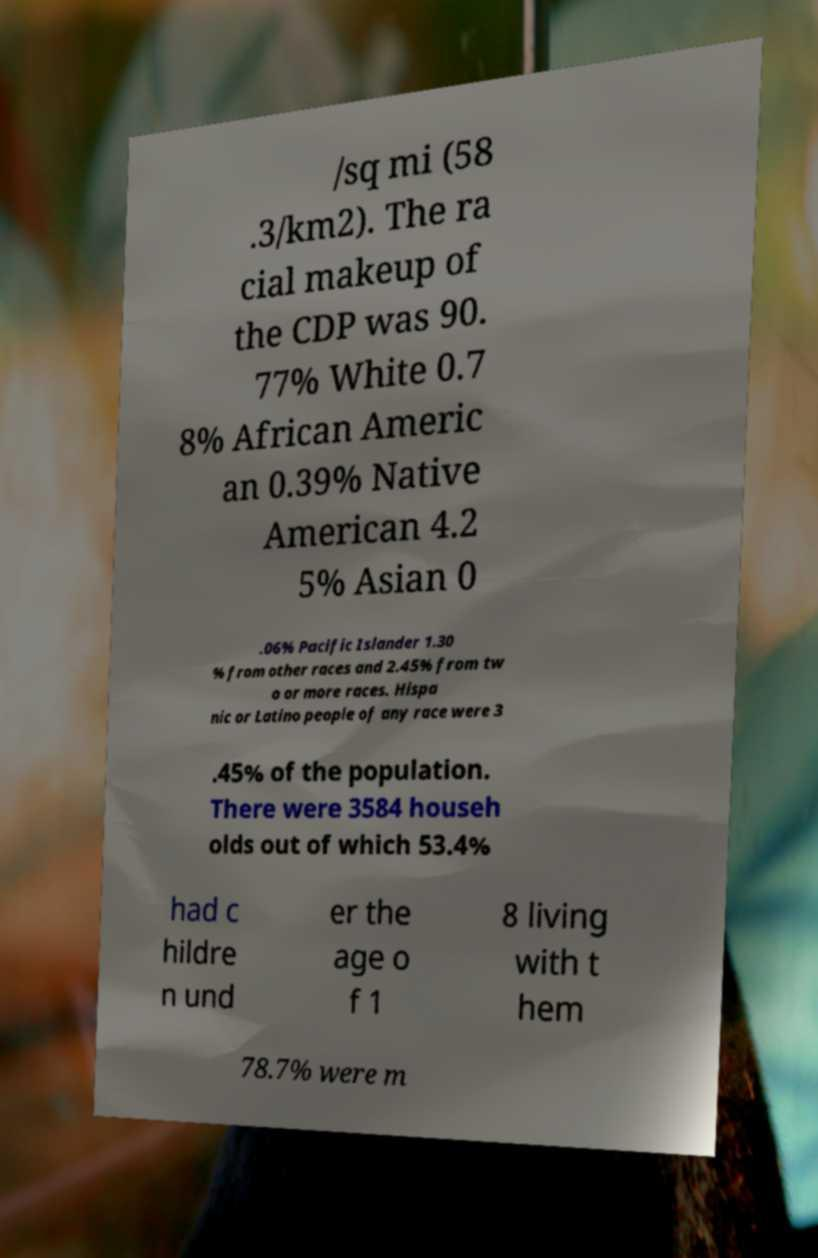Please identify and transcribe the text found in this image. /sq mi (58 .3/km2). The ra cial makeup of the CDP was 90. 77% White 0.7 8% African Americ an 0.39% Native American 4.2 5% Asian 0 .06% Pacific Islander 1.30 % from other races and 2.45% from tw o or more races. Hispa nic or Latino people of any race were 3 .45% of the population. There were 3584 househ olds out of which 53.4% had c hildre n und er the age o f 1 8 living with t hem 78.7% were m 